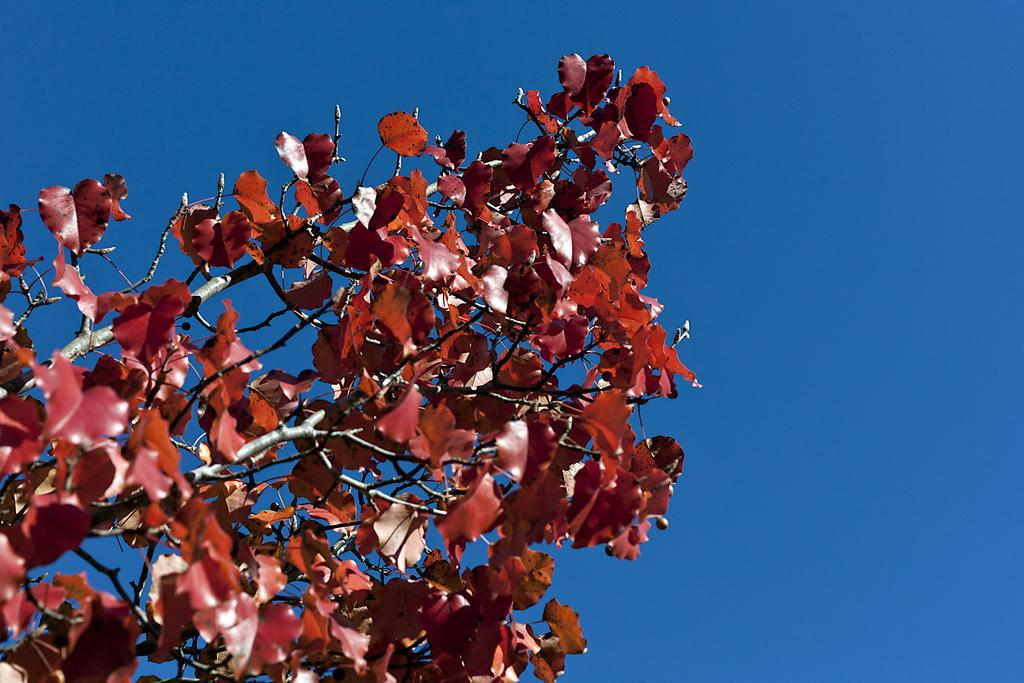What type of vegetation is visible in the image? There are branches of a tree in the image. What part of the natural environment is visible in the image? The sky is visible in the image. What type of tin can be seen hanging from the branches of the tree in the image? There is no tin present in the image; it features branches of a tree and the sky. Can you see any yaks grazing on the grass near the tree in the image? There is no yak present in the image; it only features branches of a tree and the sky. 